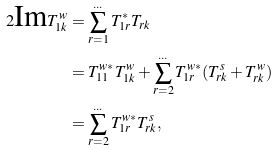<formula> <loc_0><loc_0><loc_500><loc_500>2 \text {Im} T ^ { w } _ { 1 k } & = \sum _ { r = 1 } ^ { \dots } T ^ { * } _ { 1 r } T _ { r k } \\ & = T ^ { w * } _ { 1 1 } T ^ { w } _ { 1 k } + \sum _ { r = 2 } ^ { \dots } T ^ { w * } _ { 1 r } ( T ^ { s } _ { r k } + T ^ { w } _ { r k } ) \\ & = \sum _ { r = 2 } ^ { \dots } T ^ { w * } _ { 1 r } T ^ { s } _ { r k } ,</formula> 